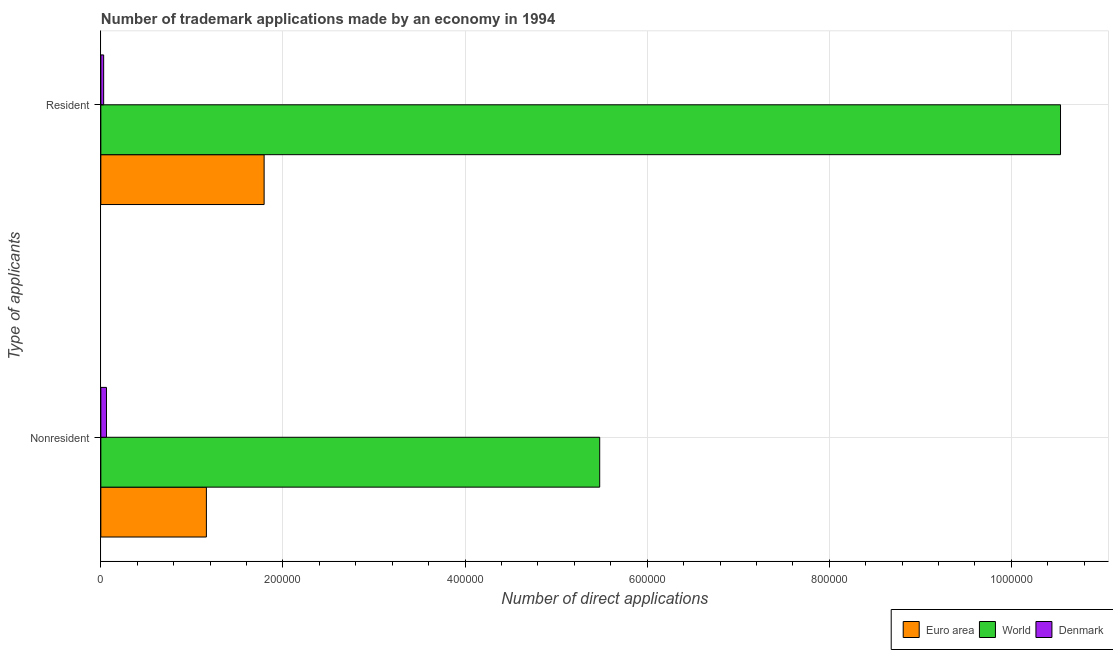How many different coloured bars are there?
Your answer should be very brief. 3. Are the number of bars on each tick of the Y-axis equal?
Keep it short and to the point. Yes. What is the label of the 2nd group of bars from the top?
Offer a very short reply. Nonresident. What is the number of trademark applications made by non residents in World?
Offer a very short reply. 5.48e+05. Across all countries, what is the maximum number of trademark applications made by residents?
Give a very brief answer. 1.05e+06. Across all countries, what is the minimum number of trademark applications made by non residents?
Your response must be concise. 6179. In which country was the number of trademark applications made by residents minimum?
Give a very brief answer. Denmark. What is the total number of trademark applications made by residents in the graph?
Your response must be concise. 1.24e+06. What is the difference between the number of trademark applications made by non residents in Euro area and that in World?
Ensure brevity in your answer.  -4.32e+05. What is the difference between the number of trademark applications made by non residents in Euro area and the number of trademark applications made by residents in World?
Your answer should be compact. -9.38e+05. What is the average number of trademark applications made by residents per country?
Make the answer very short. 4.12e+05. What is the difference between the number of trademark applications made by non residents and number of trademark applications made by residents in Euro area?
Ensure brevity in your answer.  -6.34e+04. What is the ratio of the number of trademark applications made by residents in Euro area to that in World?
Your response must be concise. 0.17. Is the number of trademark applications made by non residents in World less than that in Denmark?
Provide a succinct answer. No. What does the 2nd bar from the top in Nonresident represents?
Your answer should be very brief. World. Are all the bars in the graph horizontal?
Offer a very short reply. Yes. What is the difference between two consecutive major ticks on the X-axis?
Make the answer very short. 2.00e+05. Are the values on the major ticks of X-axis written in scientific E-notation?
Your answer should be very brief. No. Does the graph contain any zero values?
Give a very brief answer. No. Does the graph contain grids?
Provide a short and direct response. Yes. Where does the legend appear in the graph?
Provide a short and direct response. Bottom right. How are the legend labels stacked?
Provide a short and direct response. Horizontal. What is the title of the graph?
Your answer should be very brief. Number of trademark applications made by an economy in 1994. What is the label or title of the X-axis?
Ensure brevity in your answer.  Number of direct applications. What is the label or title of the Y-axis?
Provide a short and direct response. Type of applicants. What is the Number of direct applications in Euro area in Nonresident?
Provide a short and direct response. 1.16e+05. What is the Number of direct applications of World in Nonresident?
Offer a terse response. 5.48e+05. What is the Number of direct applications of Denmark in Nonresident?
Provide a short and direct response. 6179. What is the Number of direct applications of Euro area in Resident?
Your response must be concise. 1.79e+05. What is the Number of direct applications of World in Resident?
Offer a terse response. 1.05e+06. What is the Number of direct applications of Denmark in Resident?
Offer a terse response. 3098. Across all Type of applicants, what is the maximum Number of direct applications of Euro area?
Keep it short and to the point. 1.79e+05. Across all Type of applicants, what is the maximum Number of direct applications of World?
Your answer should be compact. 1.05e+06. Across all Type of applicants, what is the maximum Number of direct applications in Denmark?
Offer a very short reply. 6179. Across all Type of applicants, what is the minimum Number of direct applications of Euro area?
Make the answer very short. 1.16e+05. Across all Type of applicants, what is the minimum Number of direct applications in World?
Give a very brief answer. 5.48e+05. Across all Type of applicants, what is the minimum Number of direct applications of Denmark?
Your answer should be very brief. 3098. What is the total Number of direct applications of Euro area in the graph?
Keep it short and to the point. 2.95e+05. What is the total Number of direct applications in World in the graph?
Provide a succinct answer. 1.60e+06. What is the total Number of direct applications in Denmark in the graph?
Keep it short and to the point. 9277. What is the difference between the Number of direct applications of Euro area in Nonresident and that in Resident?
Offer a very short reply. -6.34e+04. What is the difference between the Number of direct applications in World in Nonresident and that in Resident?
Your answer should be very brief. -5.06e+05. What is the difference between the Number of direct applications of Denmark in Nonresident and that in Resident?
Make the answer very short. 3081. What is the difference between the Number of direct applications of Euro area in Nonresident and the Number of direct applications of World in Resident?
Give a very brief answer. -9.38e+05. What is the difference between the Number of direct applications of Euro area in Nonresident and the Number of direct applications of Denmark in Resident?
Give a very brief answer. 1.13e+05. What is the difference between the Number of direct applications in World in Nonresident and the Number of direct applications in Denmark in Resident?
Offer a terse response. 5.45e+05. What is the average Number of direct applications in Euro area per Type of applicants?
Provide a short and direct response. 1.48e+05. What is the average Number of direct applications of World per Type of applicants?
Your answer should be compact. 8.01e+05. What is the average Number of direct applications of Denmark per Type of applicants?
Your response must be concise. 4638.5. What is the difference between the Number of direct applications of Euro area and Number of direct applications of World in Nonresident?
Keep it short and to the point. -4.32e+05. What is the difference between the Number of direct applications in Euro area and Number of direct applications in Denmark in Nonresident?
Make the answer very short. 1.10e+05. What is the difference between the Number of direct applications in World and Number of direct applications in Denmark in Nonresident?
Offer a terse response. 5.42e+05. What is the difference between the Number of direct applications of Euro area and Number of direct applications of World in Resident?
Your answer should be compact. -8.75e+05. What is the difference between the Number of direct applications of Euro area and Number of direct applications of Denmark in Resident?
Your answer should be compact. 1.76e+05. What is the difference between the Number of direct applications of World and Number of direct applications of Denmark in Resident?
Ensure brevity in your answer.  1.05e+06. What is the ratio of the Number of direct applications of Euro area in Nonresident to that in Resident?
Ensure brevity in your answer.  0.65. What is the ratio of the Number of direct applications in World in Nonresident to that in Resident?
Provide a short and direct response. 0.52. What is the ratio of the Number of direct applications of Denmark in Nonresident to that in Resident?
Provide a succinct answer. 1.99. What is the difference between the highest and the second highest Number of direct applications in Euro area?
Offer a very short reply. 6.34e+04. What is the difference between the highest and the second highest Number of direct applications of World?
Offer a terse response. 5.06e+05. What is the difference between the highest and the second highest Number of direct applications in Denmark?
Make the answer very short. 3081. What is the difference between the highest and the lowest Number of direct applications in Euro area?
Your response must be concise. 6.34e+04. What is the difference between the highest and the lowest Number of direct applications in World?
Make the answer very short. 5.06e+05. What is the difference between the highest and the lowest Number of direct applications in Denmark?
Your response must be concise. 3081. 